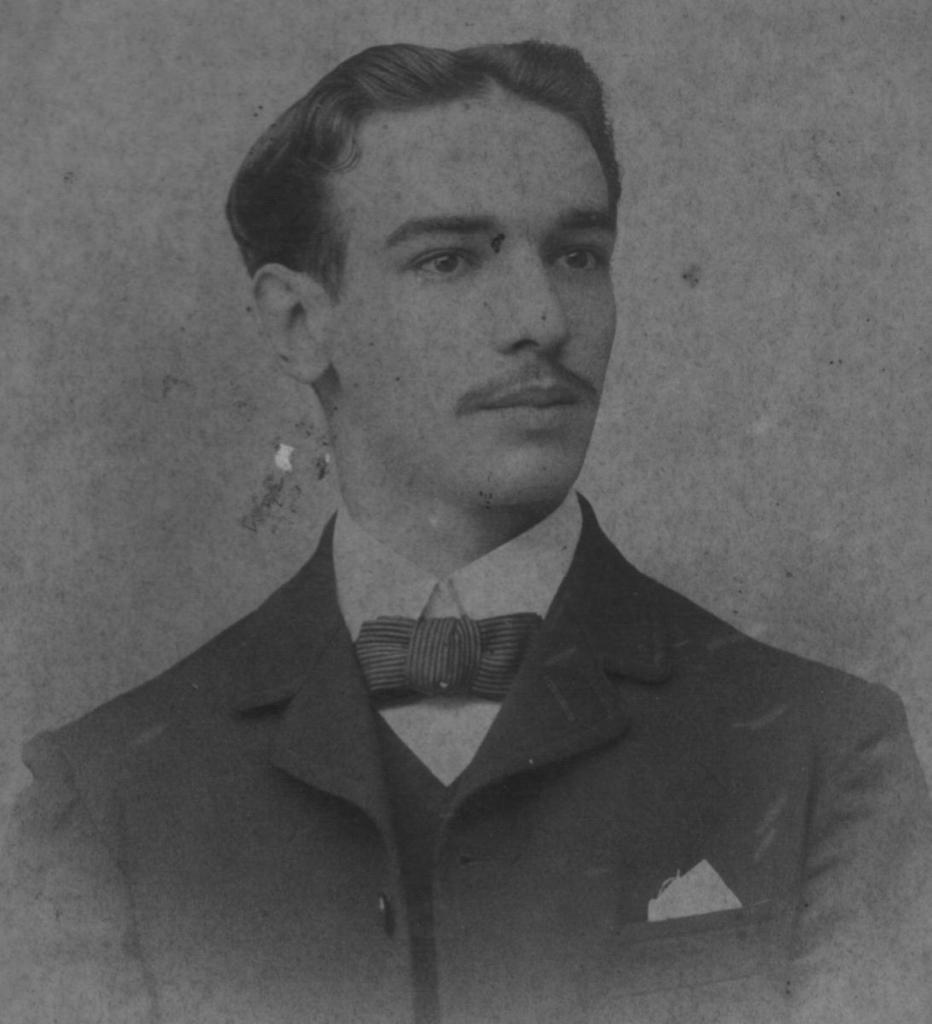What is the color scheme of the image? The image is black and white. What is the main subject of the image? There is a photograph of a person in the image. What type of clothing is the person wearing? The person is wearing a blazer and a shirt. What accessory is the person wearing in the image? The person is wearing a bow. Can you see any popcorn in the image? There is no popcorn present in the image. Is there an airplane visible in the image? No, there is no airplane in the image. 